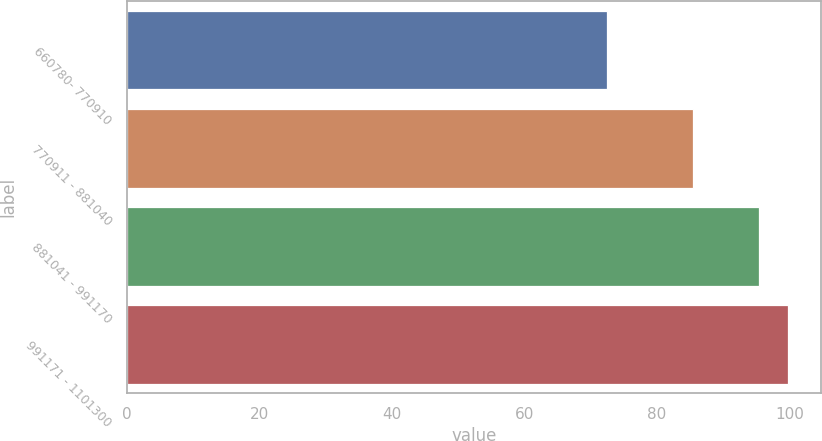<chart> <loc_0><loc_0><loc_500><loc_500><bar_chart><fcel>660780- 770910<fcel>770911 - 881040<fcel>881041 - 991170<fcel>991171 - 1101300<nl><fcel>72.47<fcel>85.52<fcel>95.38<fcel>99.73<nl></chart> 